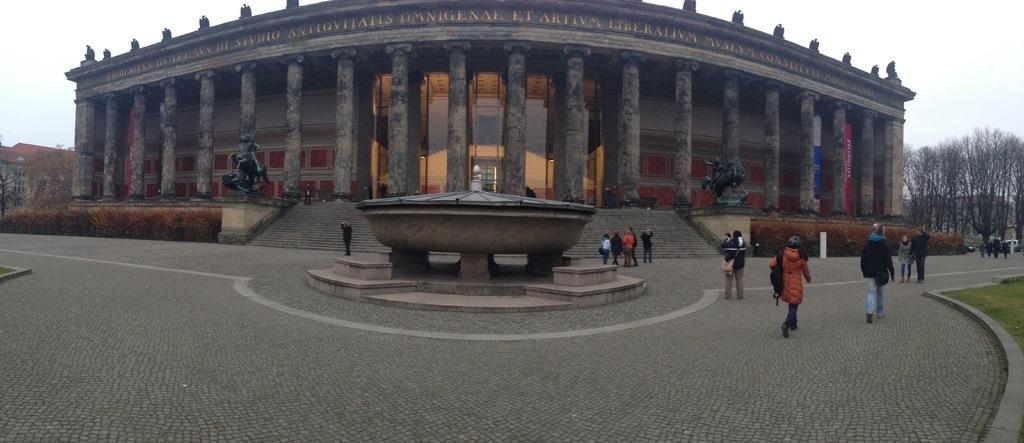In one or two sentences, can you explain what this image depicts? This picture describes about group of people, few are standing and few are walking, in the background we can see few trees, statues and buildings. 